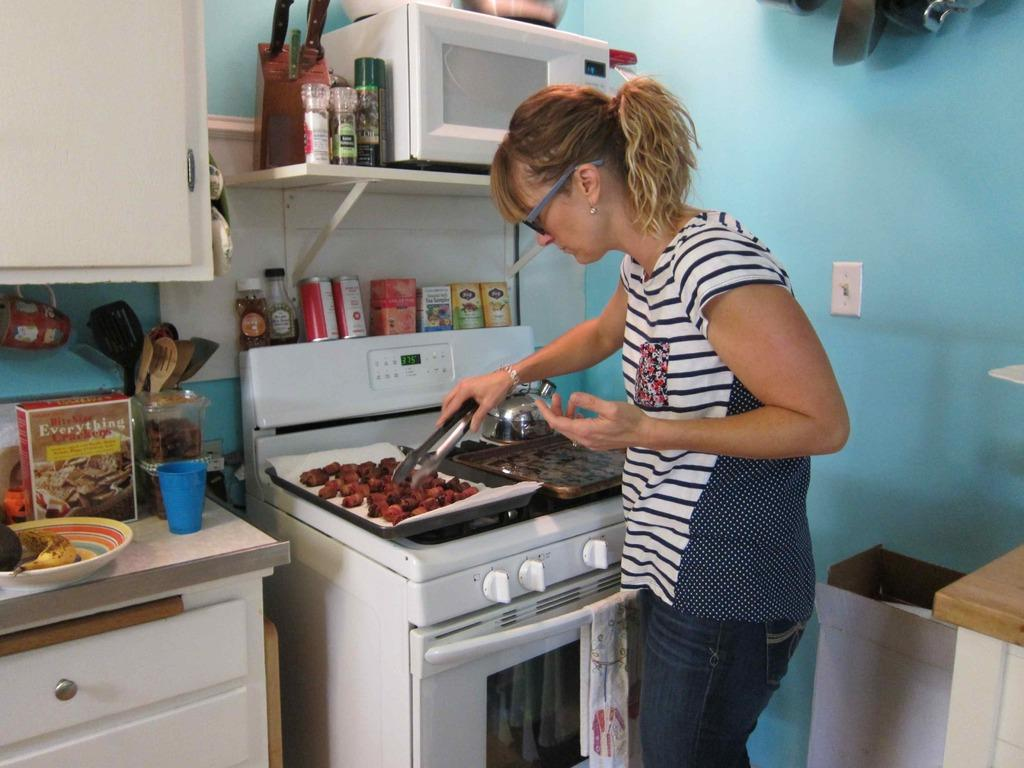<image>
Present a compact description of the photo's key features. A lady cooking on a stove next to a box of bite sized Everything Crackers. 